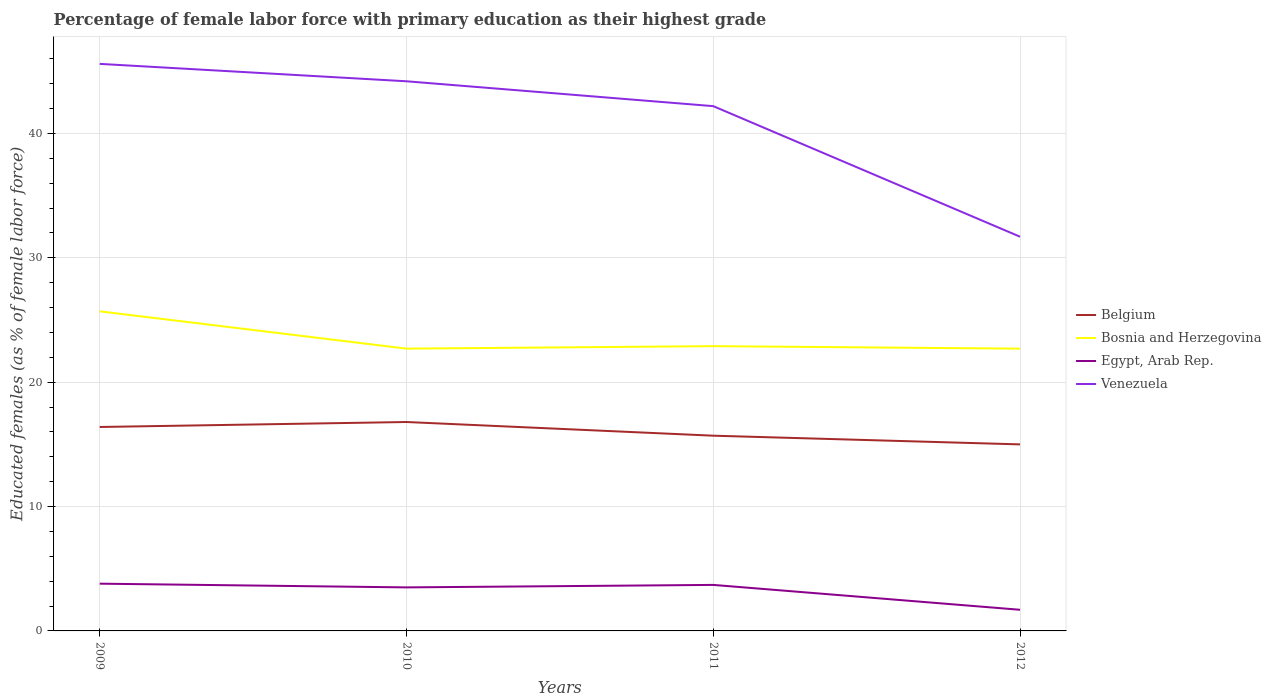How many different coloured lines are there?
Your response must be concise. 4. Does the line corresponding to Egypt, Arab Rep. intersect with the line corresponding to Venezuela?
Give a very brief answer. No. Is the number of lines equal to the number of legend labels?
Make the answer very short. Yes. Across all years, what is the maximum percentage of female labor force with primary education in Egypt, Arab Rep.?
Give a very brief answer. 1.7. In which year was the percentage of female labor force with primary education in Bosnia and Herzegovina maximum?
Keep it short and to the point. 2010. What is the total percentage of female labor force with primary education in Belgium in the graph?
Ensure brevity in your answer.  0.7. What is the difference between the highest and the second highest percentage of female labor force with primary education in Venezuela?
Your answer should be compact. 13.9. What is the difference between the highest and the lowest percentage of female labor force with primary education in Bosnia and Herzegovina?
Your answer should be compact. 1. Is the percentage of female labor force with primary education in Venezuela strictly greater than the percentage of female labor force with primary education in Egypt, Arab Rep. over the years?
Provide a succinct answer. No. How many lines are there?
Your answer should be very brief. 4. Are the values on the major ticks of Y-axis written in scientific E-notation?
Ensure brevity in your answer.  No. Where does the legend appear in the graph?
Keep it short and to the point. Center right. What is the title of the graph?
Your answer should be very brief. Percentage of female labor force with primary education as their highest grade. Does "Israel" appear as one of the legend labels in the graph?
Offer a very short reply. No. What is the label or title of the X-axis?
Give a very brief answer. Years. What is the label or title of the Y-axis?
Ensure brevity in your answer.  Educated females (as % of female labor force). What is the Educated females (as % of female labor force) of Belgium in 2009?
Provide a short and direct response. 16.4. What is the Educated females (as % of female labor force) in Bosnia and Herzegovina in 2009?
Give a very brief answer. 25.7. What is the Educated females (as % of female labor force) of Egypt, Arab Rep. in 2009?
Your answer should be compact. 3.8. What is the Educated females (as % of female labor force) in Venezuela in 2009?
Your response must be concise. 45.6. What is the Educated females (as % of female labor force) in Belgium in 2010?
Give a very brief answer. 16.8. What is the Educated females (as % of female labor force) in Bosnia and Herzegovina in 2010?
Make the answer very short. 22.7. What is the Educated females (as % of female labor force) of Egypt, Arab Rep. in 2010?
Give a very brief answer. 3.5. What is the Educated females (as % of female labor force) of Venezuela in 2010?
Keep it short and to the point. 44.2. What is the Educated females (as % of female labor force) of Belgium in 2011?
Make the answer very short. 15.7. What is the Educated females (as % of female labor force) of Bosnia and Herzegovina in 2011?
Your response must be concise. 22.9. What is the Educated females (as % of female labor force) of Egypt, Arab Rep. in 2011?
Your answer should be compact. 3.7. What is the Educated females (as % of female labor force) in Venezuela in 2011?
Your answer should be compact. 42.2. What is the Educated females (as % of female labor force) of Bosnia and Herzegovina in 2012?
Keep it short and to the point. 22.7. What is the Educated females (as % of female labor force) in Egypt, Arab Rep. in 2012?
Keep it short and to the point. 1.7. What is the Educated females (as % of female labor force) of Venezuela in 2012?
Your answer should be very brief. 31.7. Across all years, what is the maximum Educated females (as % of female labor force) in Belgium?
Your response must be concise. 16.8. Across all years, what is the maximum Educated females (as % of female labor force) in Bosnia and Herzegovina?
Offer a terse response. 25.7. Across all years, what is the maximum Educated females (as % of female labor force) in Egypt, Arab Rep.?
Provide a short and direct response. 3.8. Across all years, what is the maximum Educated females (as % of female labor force) of Venezuela?
Your answer should be very brief. 45.6. Across all years, what is the minimum Educated females (as % of female labor force) of Belgium?
Provide a succinct answer. 15. Across all years, what is the minimum Educated females (as % of female labor force) in Bosnia and Herzegovina?
Offer a very short reply. 22.7. Across all years, what is the minimum Educated females (as % of female labor force) in Egypt, Arab Rep.?
Provide a short and direct response. 1.7. Across all years, what is the minimum Educated females (as % of female labor force) of Venezuela?
Offer a very short reply. 31.7. What is the total Educated females (as % of female labor force) of Belgium in the graph?
Your answer should be very brief. 63.9. What is the total Educated females (as % of female labor force) of Bosnia and Herzegovina in the graph?
Your response must be concise. 94. What is the total Educated females (as % of female labor force) in Egypt, Arab Rep. in the graph?
Make the answer very short. 12.7. What is the total Educated females (as % of female labor force) of Venezuela in the graph?
Provide a succinct answer. 163.7. What is the difference between the Educated females (as % of female labor force) in Belgium in 2009 and that in 2010?
Your response must be concise. -0.4. What is the difference between the Educated females (as % of female labor force) of Egypt, Arab Rep. in 2009 and that in 2010?
Give a very brief answer. 0.3. What is the difference between the Educated females (as % of female labor force) in Bosnia and Herzegovina in 2009 and that in 2011?
Give a very brief answer. 2.8. What is the difference between the Educated females (as % of female labor force) in Venezuela in 2009 and that in 2011?
Offer a terse response. 3.4. What is the difference between the Educated females (as % of female labor force) of Bosnia and Herzegovina in 2009 and that in 2012?
Your answer should be very brief. 3. What is the difference between the Educated females (as % of female labor force) in Egypt, Arab Rep. in 2009 and that in 2012?
Your answer should be compact. 2.1. What is the difference between the Educated females (as % of female labor force) of Venezuela in 2010 and that in 2011?
Offer a terse response. 2. What is the difference between the Educated females (as % of female labor force) of Belgium in 2010 and that in 2012?
Offer a very short reply. 1.8. What is the difference between the Educated females (as % of female labor force) of Venezuela in 2010 and that in 2012?
Offer a terse response. 12.5. What is the difference between the Educated females (as % of female labor force) of Bosnia and Herzegovina in 2011 and that in 2012?
Your answer should be compact. 0.2. What is the difference between the Educated females (as % of female labor force) of Venezuela in 2011 and that in 2012?
Provide a short and direct response. 10.5. What is the difference between the Educated females (as % of female labor force) in Belgium in 2009 and the Educated females (as % of female labor force) in Bosnia and Herzegovina in 2010?
Provide a succinct answer. -6.3. What is the difference between the Educated females (as % of female labor force) in Belgium in 2009 and the Educated females (as % of female labor force) in Venezuela in 2010?
Offer a terse response. -27.8. What is the difference between the Educated females (as % of female labor force) of Bosnia and Herzegovina in 2009 and the Educated females (as % of female labor force) of Venezuela in 2010?
Give a very brief answer. -18.5. What is the difference between the Educated females (as % of female labor force) of Egypt, Arab Rep. in 2009 and the Educated females (as % of female labor force) of Venezuela in 2010?
Your answer should be very brief. -40.4. What is the difference between the Educated females (as % of female labor force) in Belgium in 2009 and the Educated females (as % of female labor force) in Bosnia and Herzegovina in 2011?
Provide a short and direct response. -6.5. What is the difference between the Educated females (as % of female labor force) of Belgium in 2009 and the Educated females (as % of female labor force) of Egypt, Arab Rep. in 2011?
Give a very brief answer. 12.7. What is the difference between the Educated females (as % of female labor force) in Belgium in 2009 and the Educated females (as % of female labor force) in Venezuela in 2011?
Offer a very short reply. -25.8. What is the difference between the Educated females (as % of female labor force) of Bosnia and Herzegovina in 2009 and the Educated females (as % of female labor force) of Venezuela in 2011?
Ensure brevity in your answer.  -16.5. What is the difference between the Educated females (as % of female labor force) of Egypt, Arab Rep. in 2009 and the Educated females (as % of female labor force) of Venezuela in 2011?
Ensure brevity in your answer.  -38.4. What is the difference between the Educated females (as % of female labor force) in Belgium in 2009 and the Educated females (as % of female labor force) in Egypt, Arab Rep. in 2012?
Keep it short and to the point. 14.7. What is the difference between the Educated females (as % of female labor force) in Belgium in 2009 and the Educated females (as % of female labor force) in Venezuela in 2012?
Ensure brevity in your answer.  -15.3. What is the difference between the Educated females (as % of female labor force) in Bosnia and Herzegovina in 2009 and the Educated females (as % of female labor force) in Egypt, Arab Rep. in 2012?
Your answer should be very brief. 24. What is the difference between the Educated females (as % of female labor force) of Egypt, Arab Rep. in 2009 and the Educated females (as % of female labor force) of Venezuela in 2012?
Offer a very short reply. -27.9. What is the difference between the Educated females (as % of female labor force) in Belgium in 2010 and the Educated females (as % of female labor force) in Bosnia and Herzegovina in 2011?
Make the answer very short. -6.1. What is the difference between the Educated females (as % of female labor force) of Belgium in 2010 and the Educated females (as % of female labor force) of Venezuela in 2011?
Provide a short and direct response. -25.4. What is the difference between the Educated females (as % of female labor force) of Bosnia and Herzegovina in 2010 and the Educated females (as % of female labor force) of Egypt, Arab Rep. in 2011?
Offer a very short reply. 19. What is the difference between the Educated females (as % of female labor force) in Bosnia and Herzegovina in 2010 and the Educated females (as % of female labor force) in Venezuela in 2011?
Offer a very short reply. -19.5. What is the difference between the Educated females (as % of female labor force) in Egypt, Arab Rep. in 2010 and the Educated females (as % of female labor force) in Venezuela in 2011?
Provide a short and direct response. -38.7. What is the difference between the Educated females (as % of female labor force) in Belgium in 2010 and the Educated females (as % of female labor force) in Bosnia and Herzegovina in 2012?
Keep it short and to the point. -5.9. What is the difference between the Educated females (as % of female labor force) of Belgium in 2010 and the Educated females (as % of female labor force) of Egypt, Arab Rep. in 2012?
Offer a very short reply. 15.1. What is the difference between the Educated females (as % of female labor force) in Belgium in 2010 and the Educated females (as % of female labor force) in Venezuela in 2012?
Offer a very short reply. -14.9. What is the difference between the Educated females (as % of female labor force) of Egypt, Arab Rep. in 2010 and the Educated females (as % of female labor force) of Venezuela in 2012?
Your answer should be compact. -28.2. What is the difference between the Educated females (as % of female labor force) of Belgium in 2011 and the Educated females (as % of female labor force) of Venezuela in 2012?
Your answer should be compact. -16. What is the difference between the Educated females (as % of female labor force) in Bosnia and Herzegovina in 2011 and the Educated females (as % of female labor force) in Egypt, Arab Rep. in 2012?
Your response must be concise. 21.2. What is the difference between the Educated females (as % of female labor force) of Bosnia and Herzegovina in 2011 and the Educated females (as % of female labor force) of Venezuela in 2012?
Your answer should be compact. -8.8. What is the average Educated females (as % of female labor force) of Belgium per year?
Your answer should be very brief. 15.97. What is the average Educated females (as % of female labor force) of Egypt, Arab Rep. per year?
Keep it short and to the point. 3.17. What is the average Educated females (as % of female labor force) of Venezuela per year?
Your answer should be very brief. 40.92. In the year 2009, what is the difference between the Educated females (as % of female labor force) of Belgium and Educated females (as % of female labor force) of Egypt, Arab Rep.?
Provide a short and direct response. 12.6. In the year 2009, what is the difference between the Educated females (as % of female labor force) of Belgium and Educated females (as % of female labor force) of Venezuela?
Your answer should be very brief. -29.2. In the year 2009, what is the difference between the Educated females (as % of female labor force) of Bosnia and Herzegovina and Educated females (as % of female labor force) of Egypt, Arab Rep.?
Give a very brief answer. 21.9. In the year 2009, what is the difference between the Educated females (as % of female labor force) in Bosnia and Herzegovina and Educated females (as % of female labor force) in Venezuela?
Make the answer very short. -19.9. In the year 2009, what is the difference between the Educated females (as % of female labor force) in Egypt, Arab Rep. and Educated females (as % of female labor force) in Venezuela?
Offer a terse response. -41.8. In the year 2010, what is the difference between the Educated females (as % of female labor force) in Belgium and Educated females (as % of female labor force) in Egypt, Arab Rep.?
Offer a terse response. 13.3. In the year 2010, what is the difference between the Educated females (as % of female labor force) of Belgium and Educated females (as % of female labor force) of Venezuela?
Your answer should be very brief. -27.4. In the year 2010, what is the difference between the Educated females (as % of female labor force) in Bosnia and Herzegovina and Educated females (as % of female labor force) in Egypt, Arab Rep.?
Give a very brief answer. 19.2. In the year 2010, what is the difference between the Educated females (as % of female labor force) of Bosnia and Herzegovina and Educated females (as % of female labor force) of Venezuela?
Ensure brevity in your answer.  -21.5. In the year 2010, what is the difference between the Educated females (as % of female labor force) in Egypt, Arab Rep. and Educated females (as % of female labor force) in Venezuela?
Your response must be concise. -40.7. In the year 2011, what is the difference between the Educated females (as % of female labor force) of Belgium and Educated females (as % of female labor force) of Bosnia and Herzegovina?
Ensure brevity in your answer.  -7.2. In the year 2011, what is the difference between the Educated females (as % of female labor force) of Belgium and Educated females (as % of female labor force) of Egypt, Arab Rep.?
Give a very brief answer. 12. In the year 2011, what is the difference between the Educated females (as % of female labor force) of Belgium and Educated females (as % of female labor force) of Venezuela?
Your response must be concise. -26.5. In the year 2011, what is the difference between the Educated females (as % of female labor force) of Bosnia and Herzegovina and Educated females (as % of female labor force) of Venezuela?
Offer a terse response. -19.3. In the year 2011, what is the difference between the Educated females (as % of female labor force) in Egypt, Arab Rep. and Educated females (as % of female labor force) in Venezuela?
Offer a terse response. -38.5. In the year 2012, what is the difference between the Educated females (as % of female labor force) of Belgium and Educated females (as % of female labor force) of Egypt, Arab Rep.?
Your answer should be very brief. 13.3. In the year 2012, what is the difference between the Educated females (as % of female labor force) in Belgium and Educated females (as % of female labor force) in Venezuela?
Offer a very short reply. -16.7. In the year 2012, what is the difference between the Educated females (as % of female labor force) of Bosnia and Herzegovina and Educated females (as % of female labor force) of Egypt, Arab Rep.?
Your answer should be very brief. 21. In the year 2012, what is the difference between the Educated females (as % of female labor force) of Egypt, Arab Rep. and Educated females (as % of female labor force) of Venezuela?
Provide a succinct answer. -30. What is the ratio of the Educated females (as % of female labor force) of Belgium in 2009 to that in 2010?
Make the answer very short. 0.98. What is the ratio of the Educated females (as % of female labor force) of Bosnia and Herzegovina in 2009 to that in 2010?
Keep it short and to the point. 1.13. What is the ratio of the Educated females (as % of female labor force) of Egypt, Arab Rep. in 2009 to that in 2010?
Offer a very short reply. 1.09. What is the ratio of the Educated females (as % of female labor force) in Venezuela in 2009 to that in 2010?
Your response must be concise. 1.03. What is the ratio of the Educated females (as % of female labor force) in Belgium in 2009 to that in 2011?
Offer a very short reply. 1.04. What is the ratio of the Educated females (as % of female labor force) in Bosnia and Herzegovina in 2009 to that in 2011?
Your answer should be very brief. 1.12. What is the ratio of the Educated females (as % of female labor force) of Venezuela in 2009 to that in 2011?
Your response must be concise. 1.08. What is the ratio of the Educated females (as % of female labor force) in Belgium in 2009 to that in 2012?
Provide a short and direct response. 1.09. What is the ratio of the Educated females (as % of female labor force) in Bosnia and Herzegovina in 2009 to that in 2012?
Provide a short and direct response. 1.13. What is the ratio of the Educated females (as % of female labor force) of Egypt, Arab Rep. in 2009 to that in 2012?
Make the answer very short. 2.24. What is the ratio of the Educated females (as % of female labor force) of Venezuela in 2009 to that in 2012?
Your answer should be compact. 1.44. What is the ratio of the Educated females (as % of female labor force) of Belgium in 2010 to that in 2011?
Your response must be concise. 1.07. What is the ratio of the Educated females (as % of female labor force) in Egypt, Arab Rep. in 2010 to that in 2011?
Keep it short and to the point. 0.95. What is the ratio of the Educated females (as % of female labor force) in Venezuela in 2010 to that in 2011?
Offer a very short reply. 1.05. What is the ratio of the Educated females (as % of female labor force) of Belgium in 2010 to that in 2012?
Provide a succinct answer. 1.12. What is the ratio of the Educated females (as % of female labor force) of Bosnia and Herzegovina in 2010 to that in 2012?
Your response must be concise. 1. What is the ratio of the Educated females (as % of female labor force) in Egypt, Arab Rep. in 2010 to that in 2012?
Your answer should be compact. 2.06. What is the ratio of the Educated females (as % of female labor force) in Venezuela in 2010 to that in 2012?
Keep it short and to the point. 1.39. What is the ratio of the Educated females (as % of female labor force) of Belgium in 2011 to that in 2012?
Keep it short and to the point. 1.05. What is the ratio of the Educated females (as % of female labor force) of Bosnia and Herzegovina in 2011 to that in 2012?
Your answer should be very brief. 1.01. What is the ratio of the Educated females (as % of female labor force) of Egypt, Arab Rep. in 2011 to that in 2012?
Provide a short and direct response. 2.18. What is the ratio of the Educated females (as % of female labor force) of Venezuela in 2011 to that in 2012?
Keep it short and to the point. 1.33. What is the difference between the highest and the second highest Educated females (as % of female labor force) of Belgium?
Make the answer very short. 0.4. What is the difference between the highest and the second highest Educated females (as % of female labor force) of Bosnia and Herzegovina?
Keep it short and to the point. 2.8. 